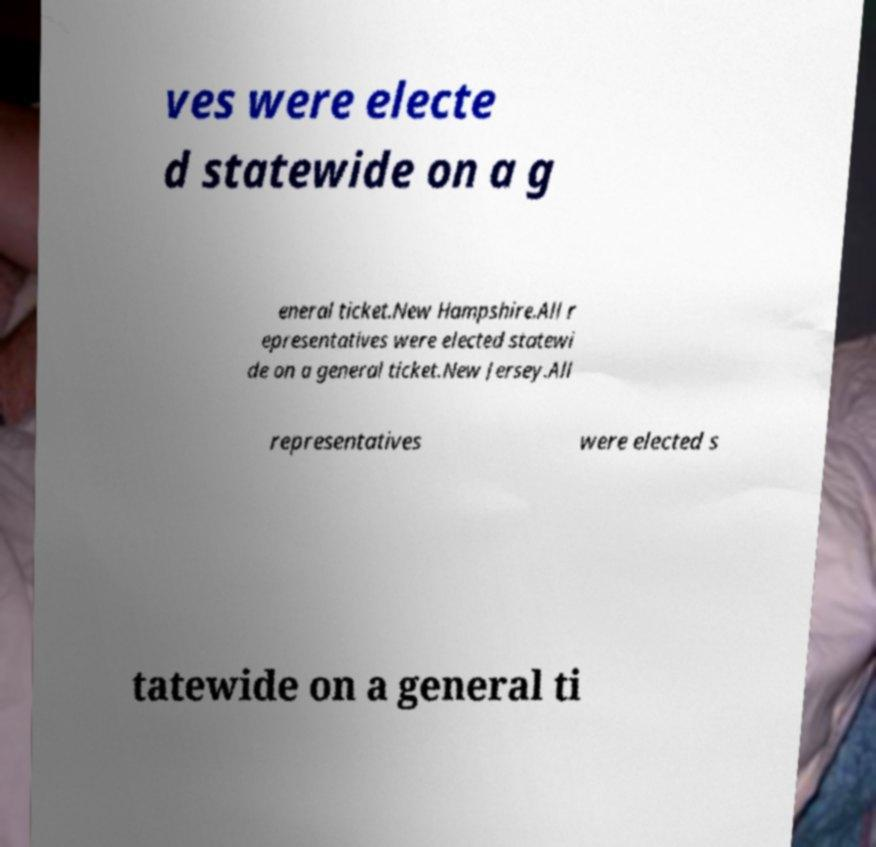Can you accurately transcribe the text from the provided image for me? ves were electe d statewide on a g eneral ticket.New Hampshire.All r epresentatives were elected statewi de on a general ticket.New Jersey.All representatives were elected s tatewide on a general ti 